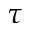Convert formula to latex. <formula><loc_0><loc_0><loc_500><loc_500>\tau</formula> 